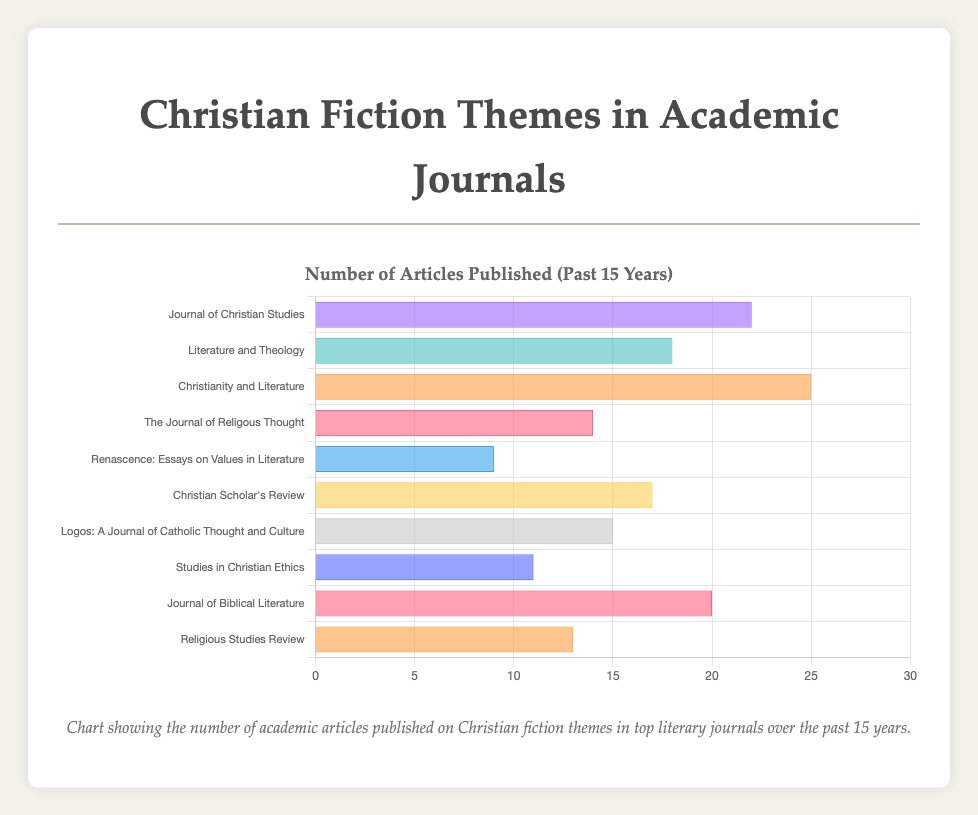Which journal published the highest number of academic articles on Christian fiction themes in the past 15 years? The figure lists the number of articles by different journals. Find the bar with the highest value. "Christianity and Literature" has 25 articles, which is the highest.
Answer: Christianity and Literature Which journal published fewer articles, "Religious Studies Review" or "Studies in Christian Ethics"? Compare the bars corresponding to these journals. "Religious Studies Review" has 13, while "Studies in Christian Ethics" has 11. Therefore, the latter published fewer articles.
Answer: Studies in Christian Ethics How many articles in total were published by "Journal of Christian Studies" and "Journal of Biblical Literature"? Add the number of articles published by both journals. "Journal of Christian Studies" has 22 and "Journal of Biblical Literature" has 20. The total is 22 + 20 = 42.
Answer: 42 What is the percentage of articles published by "Christianity and Literature" out of the total? First, sum the total number of articles (22+18+25+14+9+17+15+11+20+13 = 164). Calculate the percentage: (25/164) * 100 = 15.24%.
Answer: 15.24% Which journal is represented by the longest bar that is colored blue? Identify the journal whose bar color is blue and has the longest length. The longest blue bar corresponds to "Literature and Theology" with 18 articles.
Answer: Literature and Theology Which journal published exactly 15 articles? Look for the journal bar that represents 15 articles. "Logos: A Journal of Catholic Thought and Culture" published exactly 15 articles.
Answer: Logos: A Journal of Catholic Thought and Culture What is the average number of articles published across all journals? Sum all the articles and divide by the number of journals. (22+18+25+14+9+17+15+11+20+13) = 164. There are 10 journals, so the average is 164 / 10 = 16.4.
Answer: 16.4 How many more articles did "Christianity and Literature" publish compared to "The Journal of Religious Thought"? Subtract the number of articles of "The Journal of Religous Thought" from "Christianity and Literature". 25 - 14 = 11.
Answer: 11 What is the combined number of articles published by journals that have published fewer than 15 articles each? Identify and sum the articles from journals with fewer than 15. "The Journal of Religious Thought" (14), "Renascence: Essays on Values in Literature" (9), "Studies in Christian Ethics" (11), and "Religious Studies Review" (13). The total is 14 + 9 + 11 + 13 = 47.
Answer: 47 